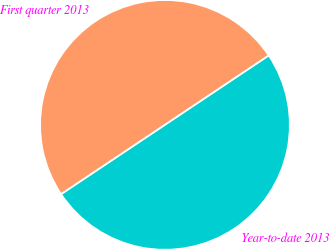<chart> <loc_0><loc_0><loc_500><loc_500><pie_chart><fcel>First quarter 2013<fcel>Year-to-date 2013<nl><fcel>50.0%<fcel>50.0%<nl></chart> 